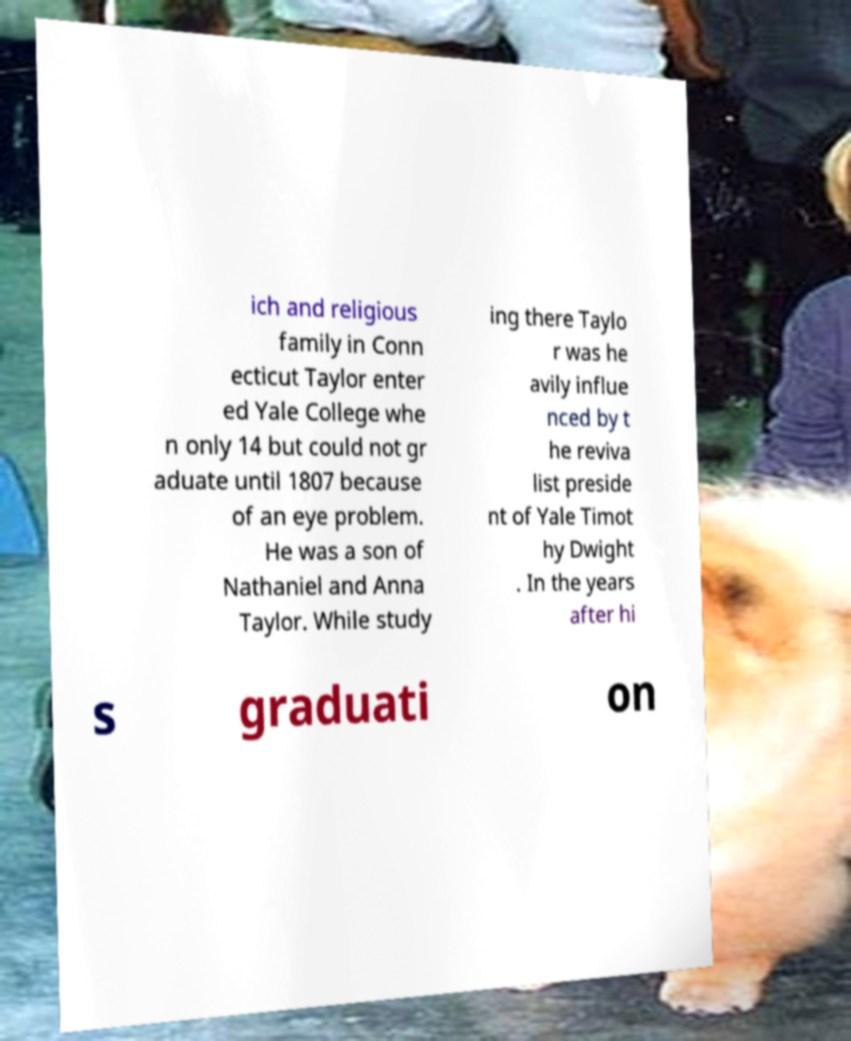Can you read and provide the text displayed in the image?This photo seems to have some interesting text. Can you extract and type it out for me? ich and religious family in Conn ecticut Taylor enter ed Yale College whe n only 14 but could not gr aduate until 1807 because of an eye problem. He was a son of Nathaniel and Anna Taylor. While study ing there Taylo r was he avily influe nced by t he reviva list preside nt of Yale Timot hy Dwight . In the years after hi s graduati on 